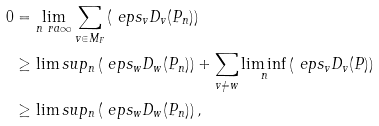Convert formula to latex. <formula><loc_0><loc_0><loc_500><loc_500>0 & = \lim _ { n \ r a \infty } \sum _ { v \in M _ { F } } \left ( \ e p s _ { v } D _ { v } ( P _ { n } ) \right ) \\ & \geq \lim s u p _ { n } \left ( \ e p s _ { w } D _ { w } ( P _ { n } ) \right ) + \sum _ { v \neq w } \liminf _ { n } \left ( \ e p s _ { v } D _ { v } ( P ) \right ) \\ & \geq \lim s u p _ { n } \left ( \ e p s _ { w } D _ { w } ( P _ { n } ) \right ) ,</formula> 